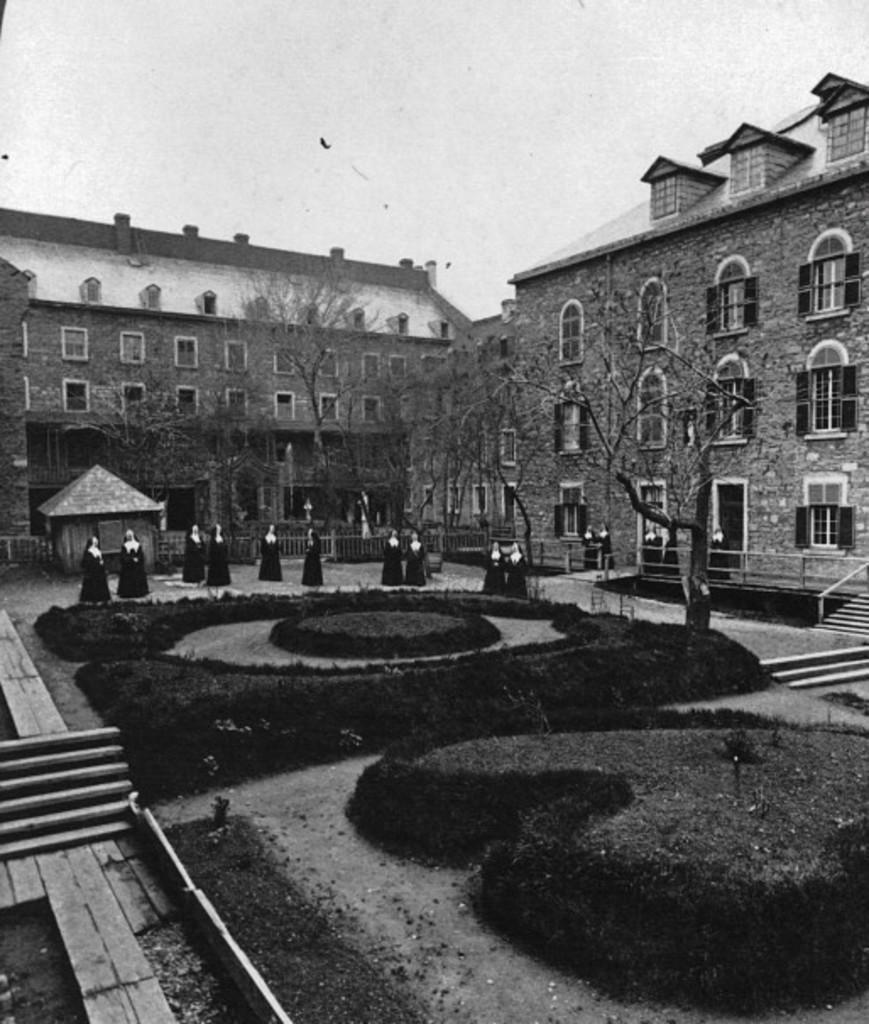Can you describe this image briefly? In this image I can see the black and white picture in which I can see the ground, few plants, few trees, few persons standing, few stairs, the railing and few buildings. In the background I can see the sky. 